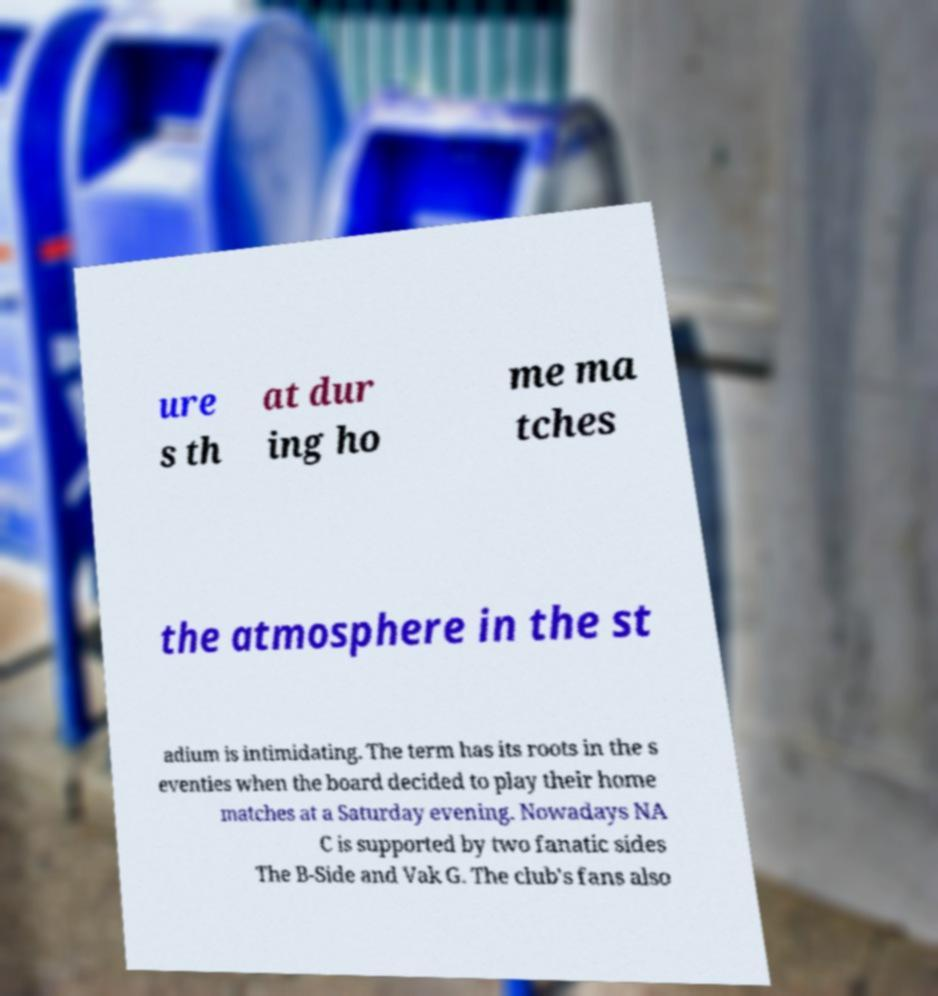There's text embedded in this image that I need extracted. Can you transcribe it verbatim? ure s th at dur ing ho me ma tches the atmosphere in the st adium is intimidating. The term has its roots in the s eventies when the board decided to play their home matches at a Saturday evening. Nowadays NA C is supported by two fanatic sides The B-Side and Vak G. The club's fans also 